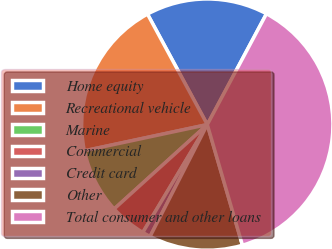<chart> <loc_0><loc_0><loc_500><loc_500><pie_chart><fcel>Home equity<fcel>Recreational vehicle<fcel>Marine<fcel>Commercial<fcel>Credit card<fcel>Other<fcel>Total consumer and other loans<nl><fcel>15.7%<fcel>20.45%<fcel>8.37%<fcel>4.71%<fcel>1.05%<fcel>12.04%<fcel>37.68%<nl></chart> 